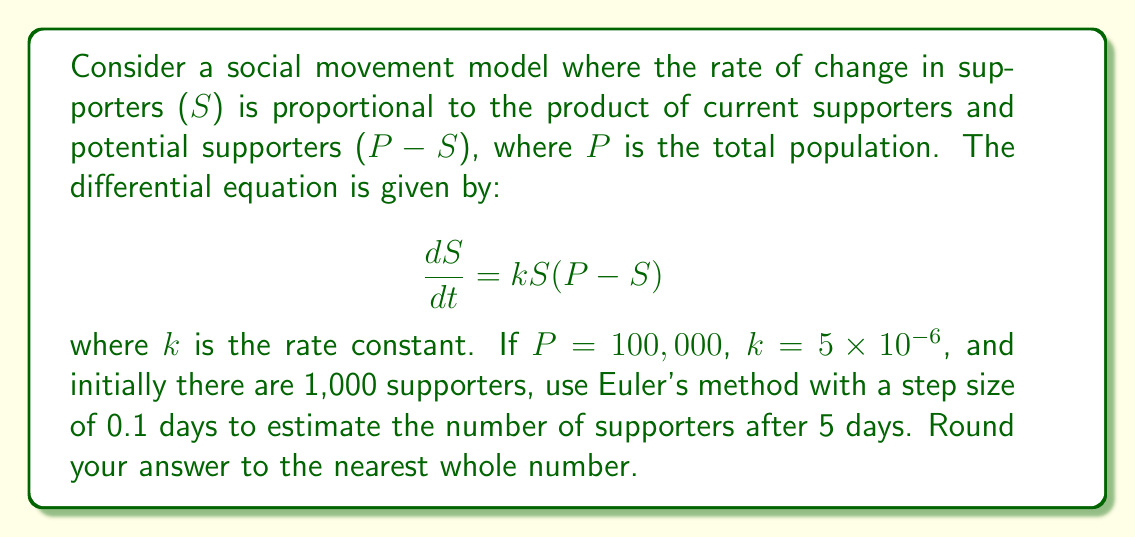Could you help me with this problem? To solve this problem using Euler's method, we follow these steps:

1) Euler's method is given by the formula:
   $$S_{n+1} = S_n + h \cdot f(t_n, S_n)$$
   where $h$ is the step size, and $f(t, S) = \frac{dS}{dt} = kS(P-S)$

2) Given:
   $P = 100,000$
   $k = 5 \times 10^{-6}$
   $S_0 = 1,000$ (initial supporters)
   $h = 0.1$ days
   We need to calculate for $t = 5$ days, so we'll need 50 steps.

3) For each step, we calculate:
   $$S_{n+1} = S_n + 0.1 \cdot (5 \times 10^{-6}) \cdot S_n \cdot (100,000 - S_n)$$

4) Let's calculate the first few steps:
   $S_1 = 1000 + 0.1 \cdot (5 \times 10^{-6}) \cdot 1000 \cdot (100,000 - 1000) = 1049.5$
   $S_2 = 1049.5 + 0.1 \cdot (5 \times 10^{-6}) \cdot 1049.5 \cdot (100,000 - 1049.5) = 1101.3$

5) We continue this process for 50 steps (5 days). Using a computer or calculator to perform these iterations, we get:

   $S_{50} \approx 4922.7$

6) Rounding to the nearest whole number, we get 4923 supporters after 5 days.
Answer: 4923 supporters 